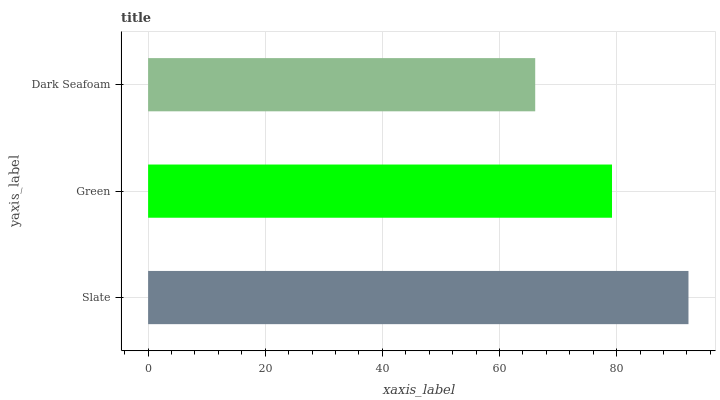Is Dark Seafoam the minimum?
Answer yes or no. Yes. Is Slate the maximum?
Answer yes or no. Yes. Is Green the minimum?
Answer yes or no. No. Is Green the maximum?
Answer yes or no. No. Is Slate greater than Green?
Answer yes or no. Yes. Is Green less than Slate?
Answer yes or no. Yes. Is Green greater than Slate?
Answer yes or no. No. Is Slate less than Green?
Answer yes or no. No. Is Green the high median?
Answer yes or no. Yes. Is Green the low median?
Answer yes or no. Yes. Is Slate the high median?
Answer yes or no. No. Is Slate the low median?
Answer yes or no. No. 